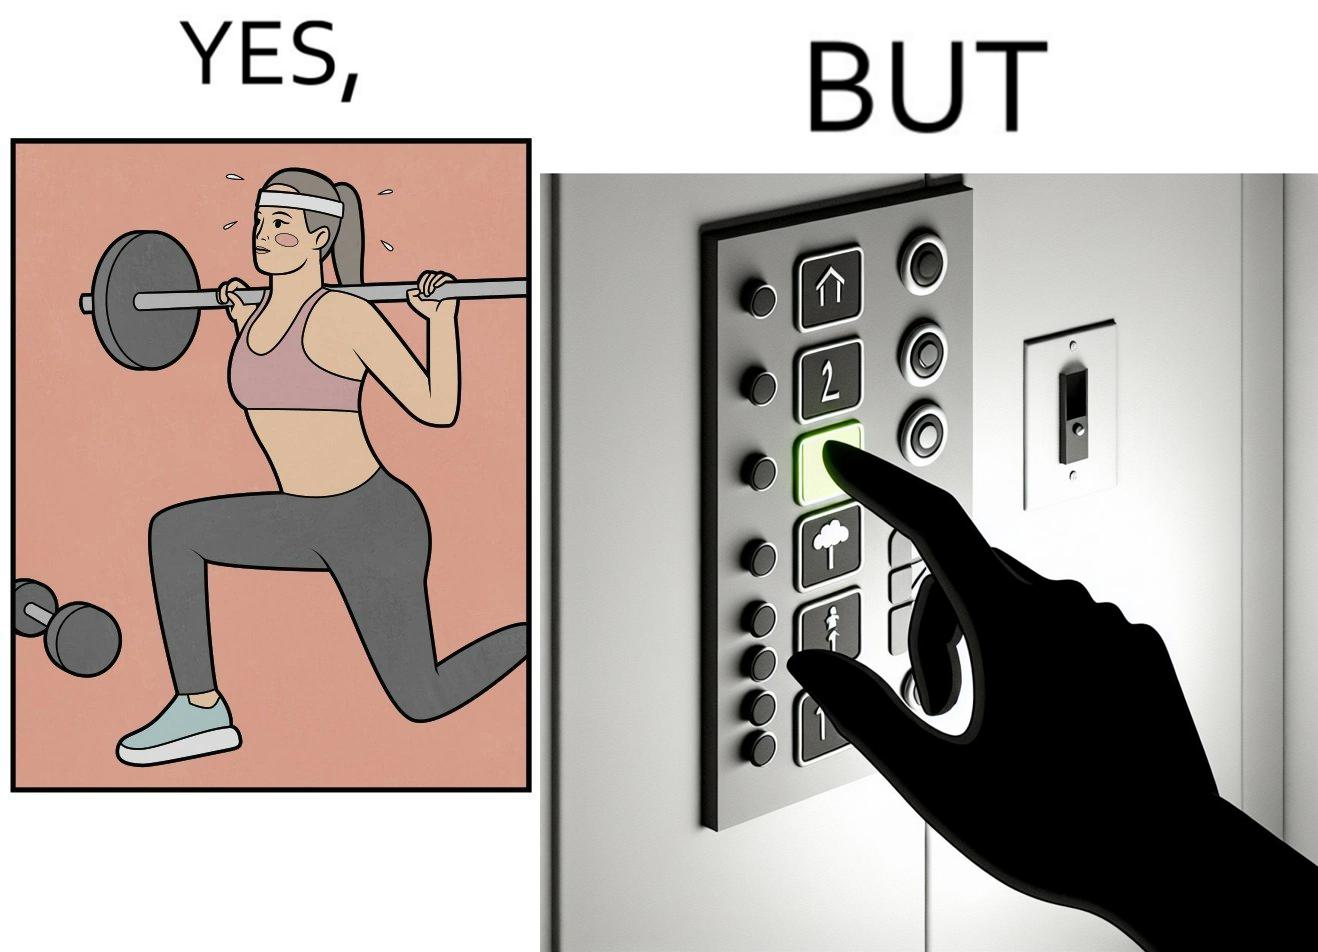Describe what you see in the left and right parts of this image. In the left part of the image: The image shows a women exercising with a bar bell in a gym. She is wearing a sport outfit. She is crouching down on one leg doing a single leg squat with a bar bell. In the right part of the image: The image shows the control panel inside of an elevator. The indicator for the first floor is green which means the button for the first floor was pressed. A hand is about to press the button for the second floor. 